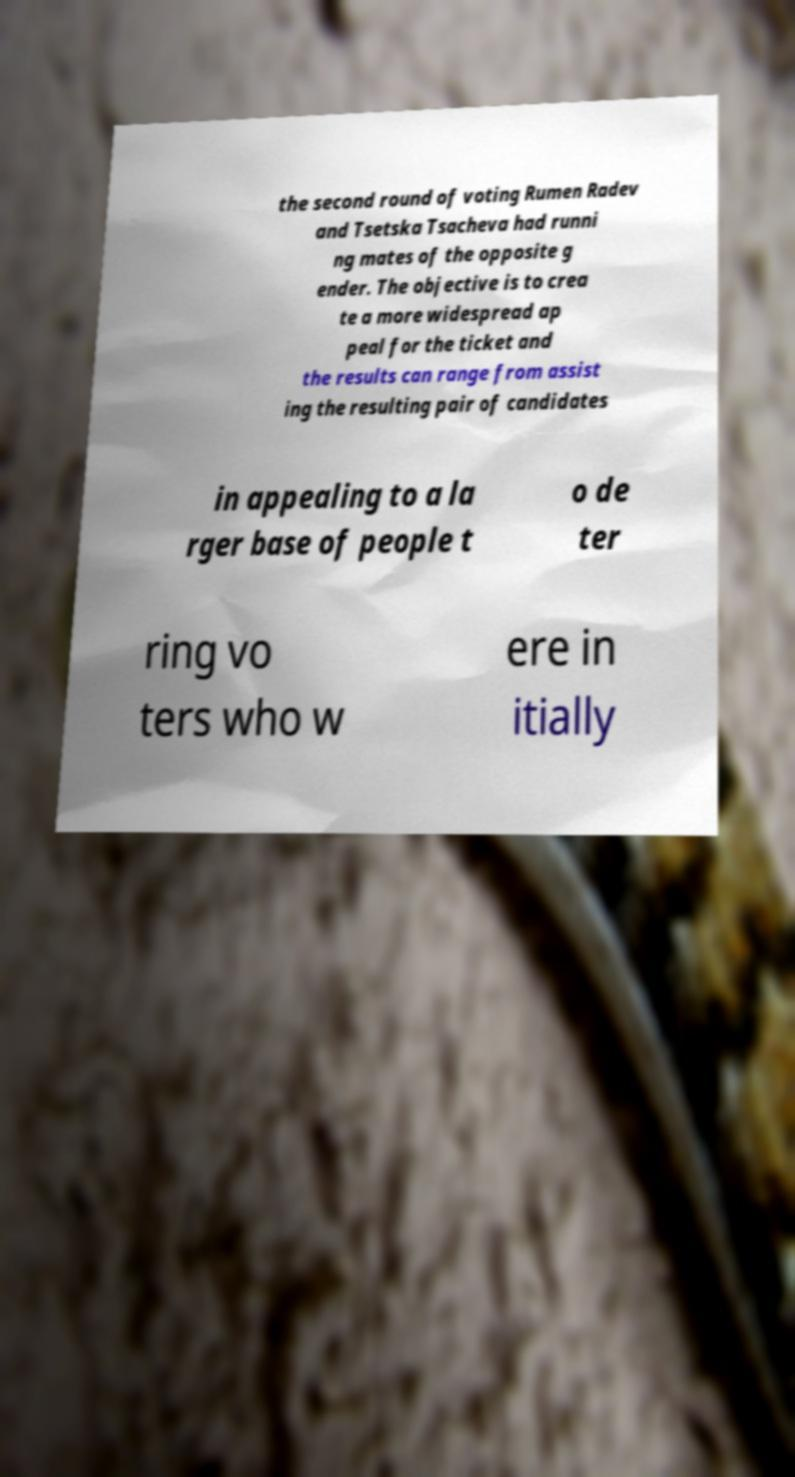I need the written content from this picture converted into text. Can you do that? the second round of voting Rumen Radev and Tsetska Tsacheva had runni ng mates of the opposite g ender. The objective is to crea te a more widespread ap peal for the ticket and the results can range from assist ing the resulting pair of candidates in appealing to a la rger base of people t o de ter ring vo ters who w ere in itially 